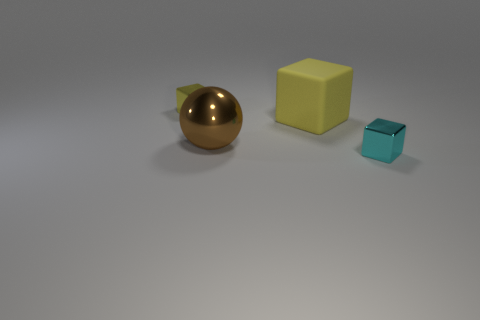Subtract all cyan cubes. Subtract all yellow cylinders. How many cubes are left? 2 Add 3 large yellow metal cubes. How many objects exist? 7 Subtract all cubes. How many objects are left? 1 Add 1 large gray rubber spheres. How many large gray rubber spheres exist? 1 Subtract 0 cyan cylinders. How many objects are left? 4 Subtract all yellow cubes. Subtract all tiny things. How many objects are left? 0 Add 2 small cyan blocks. How many small cyan blocks are left? 3 